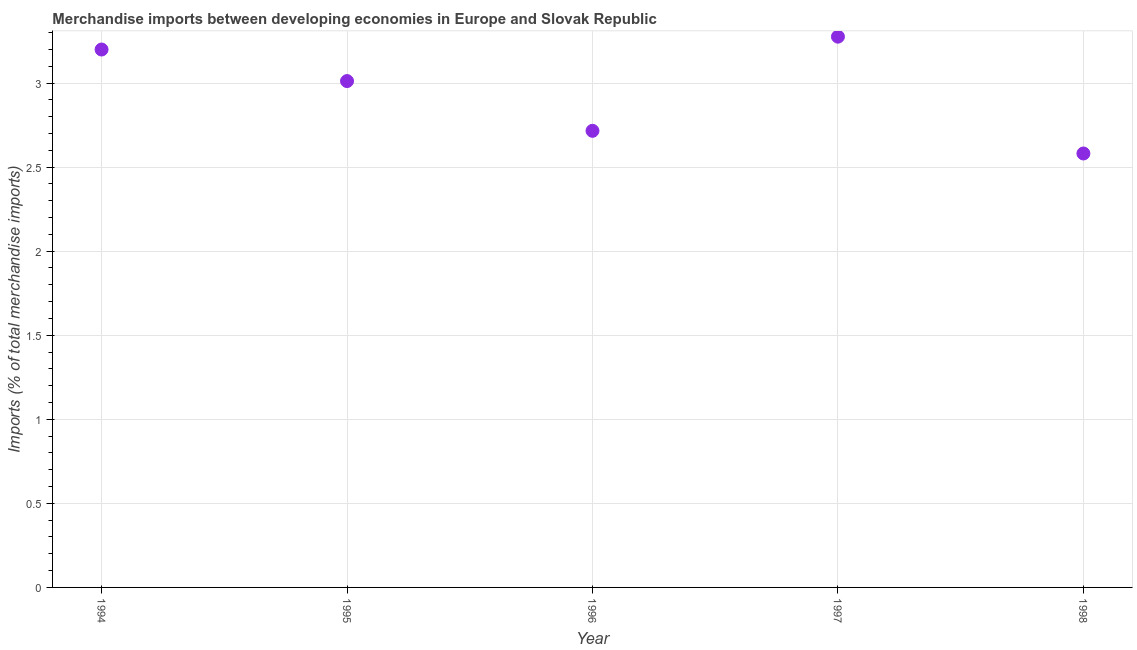What is the merchandise imports in 1998?
Give a very brief answer. 2.58. Across all years, what is the maximum merchandise imports?
Your answer should be very brief. 3.28. Across all years, what is the minimum merchandise imports?
Ensure brevity in your answer.  2.58. What is the sum of the merchandise imports?
Ensure brevity in your answer.  14.78. What is the difference between the merchandise imports in 1997 and 1998?
Offer a terse response. 0.69. What is the average merchandise imports per year?
Your answer should be compact. 2.96. What is the median merchandise imports?
Your response must be concise. 3.01. What is the ratio of the merchandise imports in 1995 to that in 1997?
Make the answer very short. 0.92. Is the difference between the merchandise imports in 1994 and 1997 greater than the difference between any two years?
Your response must be concise. No. What is the difference between the highest and the second highest merchandise imports?
Provide a short and direct response. 0.08. Is the sum of the merchandise imports in 1995 and 1997 greater than the maximum merchandise imports across all years?
Provide a short and direct response. Yes. What is the difference between the highest and the lowest merchandise imports?
Your response must be concise. 0.69. Does the merchandise imports monotonically increase over the years?
Your answer should be very brief. No. Are the values on the major ticks of Y-axis written in scientific E-notation?
Your answer should be very brief. No. Does the graph contain grids?
Give a very brief answer. Yes. What is the title of the graph?
Your answer should be compact. Merchandise imports between developing economies in Europe and Slovak Republic. What is the label or title of the X-axis?
Keep it short and to the point. Year. What is the label or title of the Y-axis?
Offer a very short reply. Imports (% of total merchandise imports). What is the Imports (% of total merchandise imports) in 1994?
Offer a terse response. 3.2. What is the Imports (% of total merchandise imports) in 1995?
Make the answer very short. 3.01. What is the Imports (% of total merchandise imports) in 1996?
Your answer should be compact. 2.72. What is the Imports (% of total merchandise imports) in 1997?
Give a very brief answer. 3.28. What is the Imports (% of total merchandise imports) in 1998?
Offer a terse response. 2.58. What is the difference between the Imports (% of total merchandise imports) in 1994 and 1995?
Give a very brief answer. 0.19. What is the difference between the Imports (% of total merchandise imports) in 1994 and 1996?
Ensure brevity in your answer.  0.48. What is the difference between the Imports (% of total merchandise imports) in 1994 and 1997?
Keep it short and to the point. -0.08. What is the difference between the Imports (% of total merchandise imports) in 1994 and 1998?
Offer a very short reply. 0.62. What is the difference between the Imports (% of total merchandise imports) in 1995 and 1996?
Offer a very short reply. 0.3. What is the difference between the Imports (% of total merchandise imports) in 1995 and 1997?
Your answer should be compact. -0.26. What is the difference between the Imports (% of total merchandise imports) in 1995 and 1998?
Provide a short and direct response. 0.43. What is the difference between the Imports (% of total merchandise imports) in 1996 and 1997?
Offer a very short reply. -0.56. What is the difference between the Imports (% of total merchandise imports) in 1996 and 1998?
Give a very brief answer. 0.13. What is the difference between the Imports (% of total merchandise imports) in 1997 and 1998?
Provide a short and direct response. 0.69. What is the ratio of the Imports (% of total merchandise imports) in 1994 to that in 1995?
Your answer should be very brief. 1.06. What is the ratio of the Imports (% of total merchandise imports) in 1994 to that in 1996?
Make the answer very short. 1.18. What is the ratio of the Imports (% of total merchandise imports) in 1994 to that in 1998?
Offer a terse response. 1.24. What is the ratio of the Imports (% of total merchandise imports) in 1995 to that in 1996?
Offer a very short reply. 1.11. What is the ratio of the Imports (% of total merchandise imports) in 1995 to that in 1997?
Provide a succinct answer. 0.92. What is the ratio of the Imports (% of total merchandise imports) in 1995 to that in 1998?
Your response must be concise. 1.17. What is the ratio of the Imports (% of total merchandise imports) in 1996 to that in 1997?
Ensure brevity in your answer.  0.83. What is the ratio of the Imports (% of total merchandise imports) in 1996 to that in 1998?
Your response must be concise. 1.05. What is the ratio of the Imports (% of total merchandise imports) in 1997 to that in 1998?
Provide a short and direct response. 1.27. 